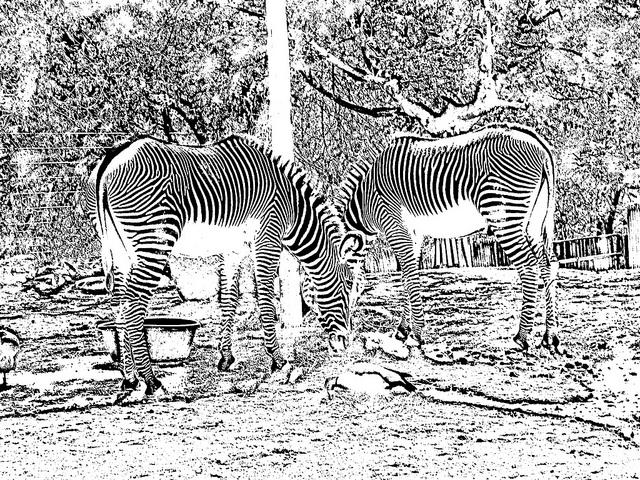How was the photo turned black and white?

Choices:
A) weather
B) filter
C) crayons
D) time filter 